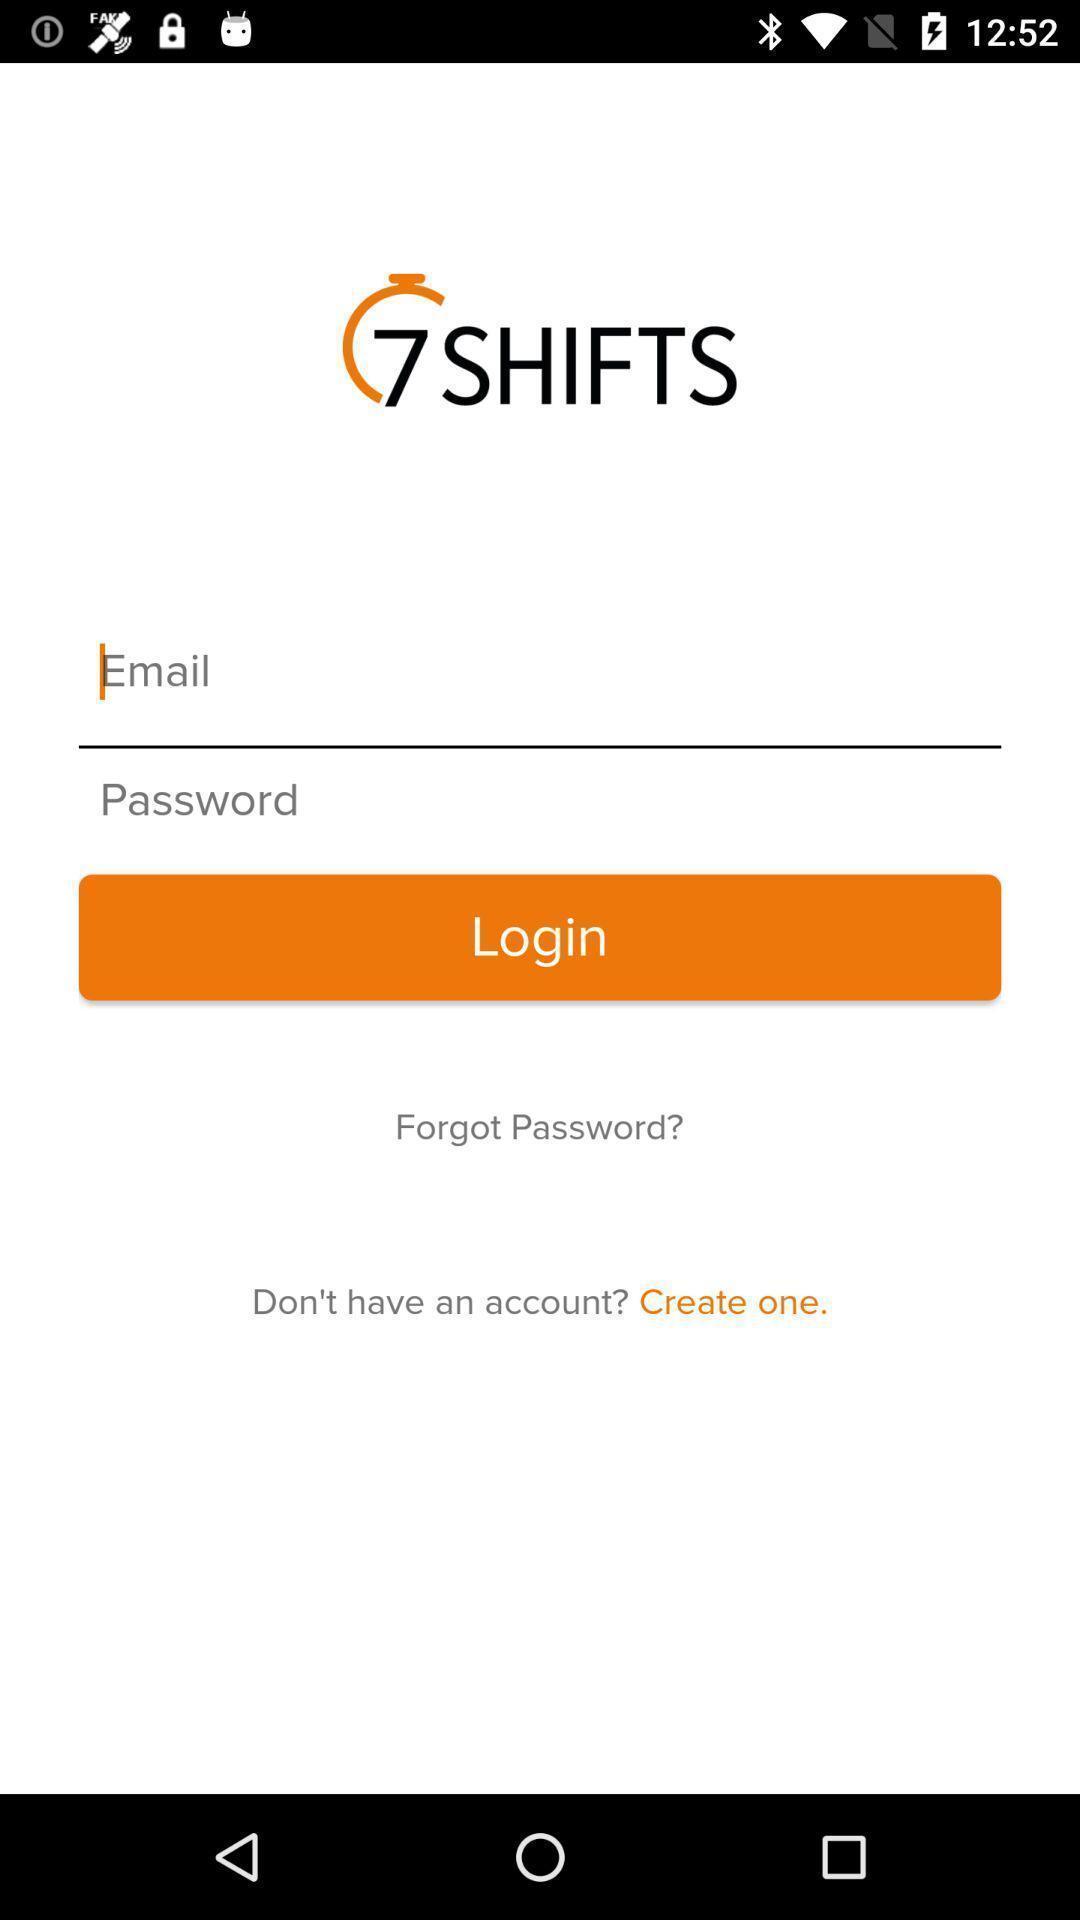Provide a description of this screenshot. Welcome page. 